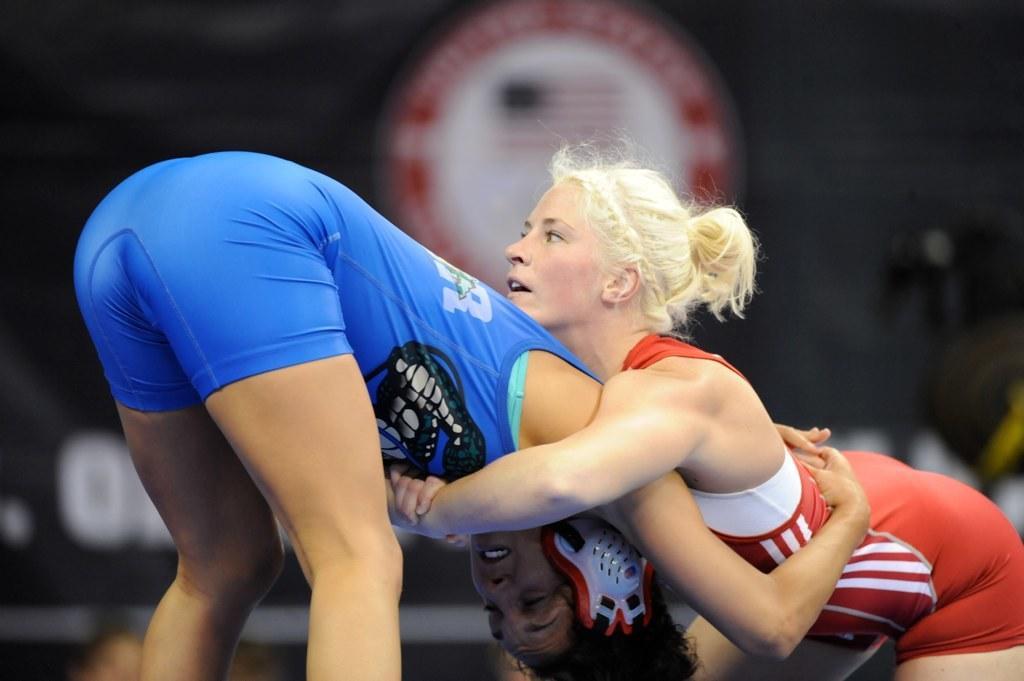How would you summarize this image in a sentence or two? On the right there is a woman who is wearing red dress, beside her we can see another woman who is wearing blue dress. Both of them are doing wrestling. In the background we can see the poster and banner. 